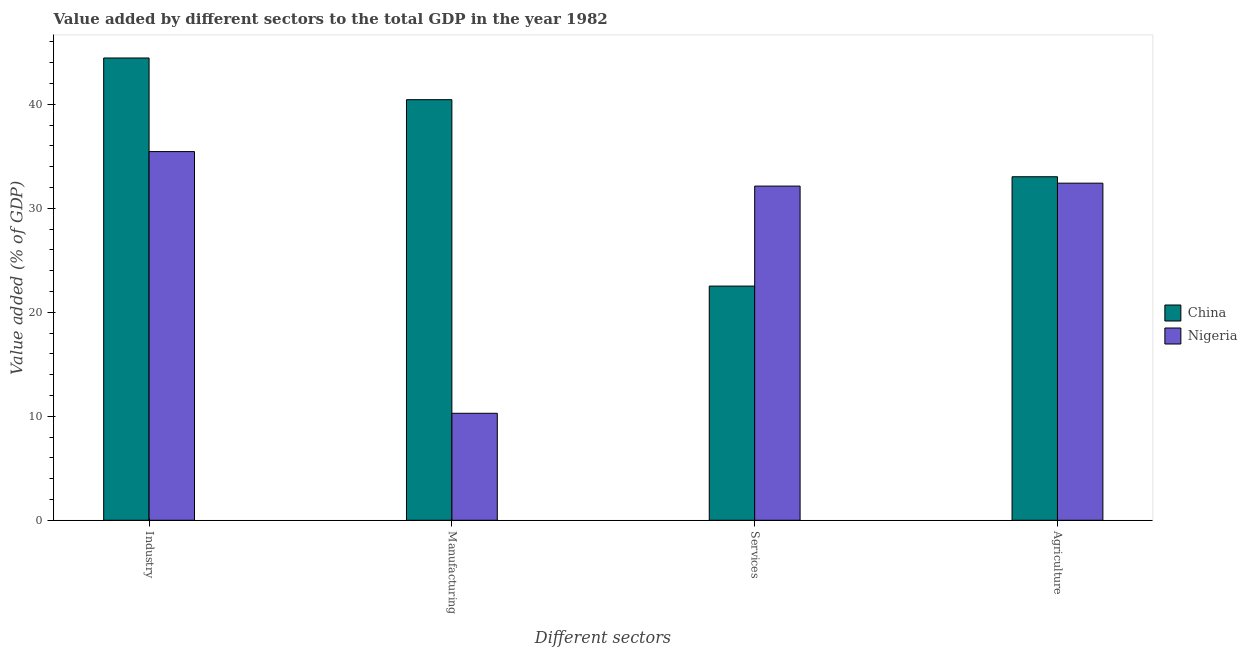How many groups of bars are there?
Your response must be concise. 4. How many bars are there on the 2nd tick from the right?
Ensure brevity in your answer.  2. What is the label of the 4th group of bars from the left?
Make the answer very short. Agriculture. What is the value added by manufacturing sector in China?
Offer a very short reply. 40.44. Across all countries, what is the maximum value added by services sector?
Your answer should be compact. 32.13. Across all countries, what is the minimum value added by manufacturing sector?
Give a very brief answer. 10.29. In which country was the value added by industrial sector minimum?
Ensure brevity in your answer.  Nigeria. What is the total value added by services sector in the graph?
Give a very brief answer. 54.65. What is the difference between the value added by agricultural sector in Nigeria and that in China?
Your response must be concise. -0.62. What is the difference between the value added by manufacturing sector in China and the value added by agricultural sector in Nigeria?
Ensure brevity in your answer.  8.03. What is the average value added by services sector per country?
Make the answer very short. 27.33. What is the difference between the value added by industrial sector and value added by services sector in Nigeria?
Your answer should be very brief. 3.32. In how many countries, is the value added by agricultural sector greater than 6 %?
Provide a succinct answer. 2. What is the ratio of the value added by agricultural sector in Nigeria to that in China?
Your response must be concise. 0.98. Is the value added by manufacturing sector in Nigeria less than that in China?
Offer a very short reply. Yes. Is the difference between the value added by industrial sector in Nigeria and China greater than the difference between the value added by manufacturing sector in Nigeria and China?
Keep it short and to the point. Yes. What is the difference between the highest and the second highest value added by services sector?
Offer a terse response. 9.62. What is the difference between the highest and the lowest value added by manufacturing sector?
Keep it short and to the point. 30.16. In how many countries, is the value added by agricultural sector greater than the average value added by agricultural sector taken over all countries?
Make the answer very short. 1. Is the sum of the value added by agricultural sector in China and Nigeria greater than the maximum value added by industrial sector across all countries?
Offer a terse response. Yes. Is it the case that in every country, the sum of the value added by services sector and value added by industrial sector is greater than the sum of value added by agricultural sector and value added by manufacturing sector?
Your response must be concise. Yes. What does the 1st bar from the left in Agriculture represents?
Provide a succinct answer. China. What does the 2nd bar from the right in Agriculture represents?
Ensure brevity in your answer.  China. How many bars are there?
Offer a very short reply. 8. Are all the bars in the graph horizontal?
Ensure brevity in your answer.  No. How many countries are there in the graph?
Your answer should be compact. 2. What is the difference between two consecutive major ticks on the Y-axis?
Make the answer very short. 10. What is the title of the graph?
Your answer should be compact. Value added by different sectors to the total GDP in the year 1982. What is the label or title of the X-axis?
Your response must be concise. Different sectors. What is the label or title of the Y-axis?
Your answer should be compact. Value added (% of GDP). What is the Value added (% of GDP) of China in Industry?
Make the answer very short. 44.45. What is the Value added (% of GDP) of Nigeria in Industry?
Keep it short and to the point. 35.45. What is the Value added (% of GDP) in China in Manufacturing?
Your answer should be very brief. 40.44. What is the Value added (% of GDP) of Nigeria in Manufacturing?
Provide a succinct answer. 10.29. What is the Value added (% of GDP) of China in Services?
Provide a short and direct response. 22.52. What is the Value added (% of GDP) in Nigeria in Services?
Keep it short and to the point. 32.13. What is the Value added (% of GDP) of China in Agriculture?
Provide a succinct answer. 33.03. What is the Value added (% of GDP) in Nigeria in Agriculture?
Offer a very short reply. 32.41. Across all Different sectors, what is the maximum Value added (% of GDP) in China?
Make the answer very short. 44.45. Across all Different sectors, what is the maximum Value added (% of GDP) of Nigeria?
Ensure brevity in your answer.  35.45. Across all Different sectors, what is the minimum Value added (% of GDP) of China?
Provide a short and direct response. 22.52. Across all Different sectors, what is the minimum Value added (% of GDP) of Nigeria?
Give a very brief answer. 10.29. What is the total Value added (% of GDP) in China in the graph?
Provide a short and direct response. 140.44. What is the total Value added (% of GDP) in Nigeria in the graph?
Your answer should be very brief. 110.29. What is the difference between the Value added (% of GDP) of China in Industry and that in Manufacturing?
Offer a very short reply. 4.01. What is the difference between the Value added (% of GDP) in Nigeria in Industry and that in Manufacturing?
Provide a succinct answer. 25.17. What is the difference between the Value added (% of GDP) in China in Industry and that in Services?
Give a very brief answer. 21.93. What is the difference between the Value added (% of GDP) in Nigeria in Industry and that in Services?
Provide a short and direct response. 3.32. What is the difference between the Value added (% of GDP) of China in Industry and that in Agriculture?
Give a very brief answer. 11.42. What is the difference between the Value added (% of GDP) of Nigeria in Industry and that in Agriculture?
Provide a short and direct response. 3.04. What is the difference between the Value added (% of GDP) of China in Manufacturing and that in Services?
Keep it short and to the point. 17.92. What is the difference between the Value added (% of GDP) of Nigeria in Manufacturing and that in Services?
Your response must be concise. -21.85. What is the difference between the Value added (% of GDP) of China in Manufacturing and that in Agriculture?
Your answer should be compact. 7.41. What is the difference between the Value added (% of GDP) in Nigeria in Manufacturing and that in Agriculture?
Your answer should be compact. -22.13. What is the difference between the Value added (% of GDP) of China in Services and that in Agriculture?
Make the answer very short. -10.51. What is the difference between the Value added (% of GDP) in Nigeria in Services and that in Agriculture?
Your response must be concise. -0.28. What is the difference between the Value added (% of GDP) of China in Industry and the Value added (% of GDP) of Nigeria in Manufacturing?
Give a very brief answer. 34.16. What is the difference between the Value added (% of GDP) in China in Industry and the Value added (% of GDP) in Nigeria in Services?
Give a very brief answer. 12.32. What is the difference between the Value added (% of GDP) in China in Industry and the Value added (% of GDP) in Nigeria in Agriculture?
Your answer should be very brief. 12.04. What is the difference between the Value added (% of GDP) of China in Manufacturing and the Value added (% of GDP) of Nigeria in Services?
Make the answer very short. 8.31. What is the difference between the Value added (% of GDP) in China in Manufacturing and the Value added (% of GDP) in Nigeria in Agriculture?
Offer a terse response. 8.03. What is the difference between the Value added (% of GDP) of China in Services and the Value added (% of GDP) of Nigeria in Agriculture?
Your answer should be compact. -9.9. What is the average Value added (% of GDP) of China per Different sectors?
Provide a succinct answer. 35.11. What is the average Value added (% of GDP) of Nigeria per Different sectors?
Make the answer very short. 27.57. What is the difference between the Value added (% of GDP) in China and Value added (% of GDP) in Nigeria in Industry?
Your answer should be compact. 9. What is the difference between the Value added (% of GDP) in China and Value added (% of GDP) in Nigeria in Manufacturing?
Your response must be concise. 30.16. What is the difference between the Value added (% of GDP) in China and Value added (% of GDP) in Nigeria in Services?
Offer a very short reply. -9.62. What is the difference between the Value added (% of GDP) in China and Value added (% of GDP) in Nigeria in Agriculture?
Keep it short and to the point. 0.62. What is the ratio of the Value added (% of GDP) in China in Industry to that in Manufacturing?
Ensure brevity in your answer.  1.1. What is the ratio of the Value added (% of GDP) of Nigeria in Industry to that in Manufacturing?
Offer a very short reply. 3.45. What is the ratio of the Value added (% of GDP) of China in Industry to that in Services?
Your answer should be compact. 1.97. What is the ratio of the Value added (% of GDP) of Nigeria in Industry to that in Services?
Offer a very short reply. 1.1. What is the ratio of the Value added (% of GDP) of China in Industry to that in Agriculture?
Your answer should be compact. 1.35. What is the ratio of the Value added (% of GDP) in Nigeria in Industry to that in Agriculture?
Provide a short and direct response. 1.09. What is the ratio of the Value added (% of GDP) in China in Manufacturing to that in Services?
Ensure brevity in your answer.  1.8. What is the ratio of the Value added (% of GDP) of Nigeria in Manufacturing to that in Services?
Your answer should be very brief. 0.32. What is the ratio of the Value added (% of GDP) of China in Manufacturing to that in Agriculture?
Provide a succinct answer. 1.22. What is the ratio of the Value added (% of GDP) in Nigeria in Manufacturing to that in Agriculture?
Ensure brevity in your answer.  0.32. What is the ratio of the Value added (% of GDP) of China in Services to that in Agriculture?
Keep it short and to the point. 0.68. What is the ratio of the Value added (% of GDP) in Nigeria in Services to that in Agriculture?
Give a very brief answer. 0.99. What is the difference between the highest and the second highest Value added (% of GDP) in China?
Offer a terse response. 4.01. What is the difference between the highest and the second highest Value added (% of GDP) in Nigeria?
Offer a terse response. 3.04. What is the difference between the highest and the lowest Value added (% of GDP) in China?
Offer a very short reply. 21.93. What is the difference between the highest and the lowest Value added (% of GDP) of Nigeria?
Your answer should be compact. 25.17. 